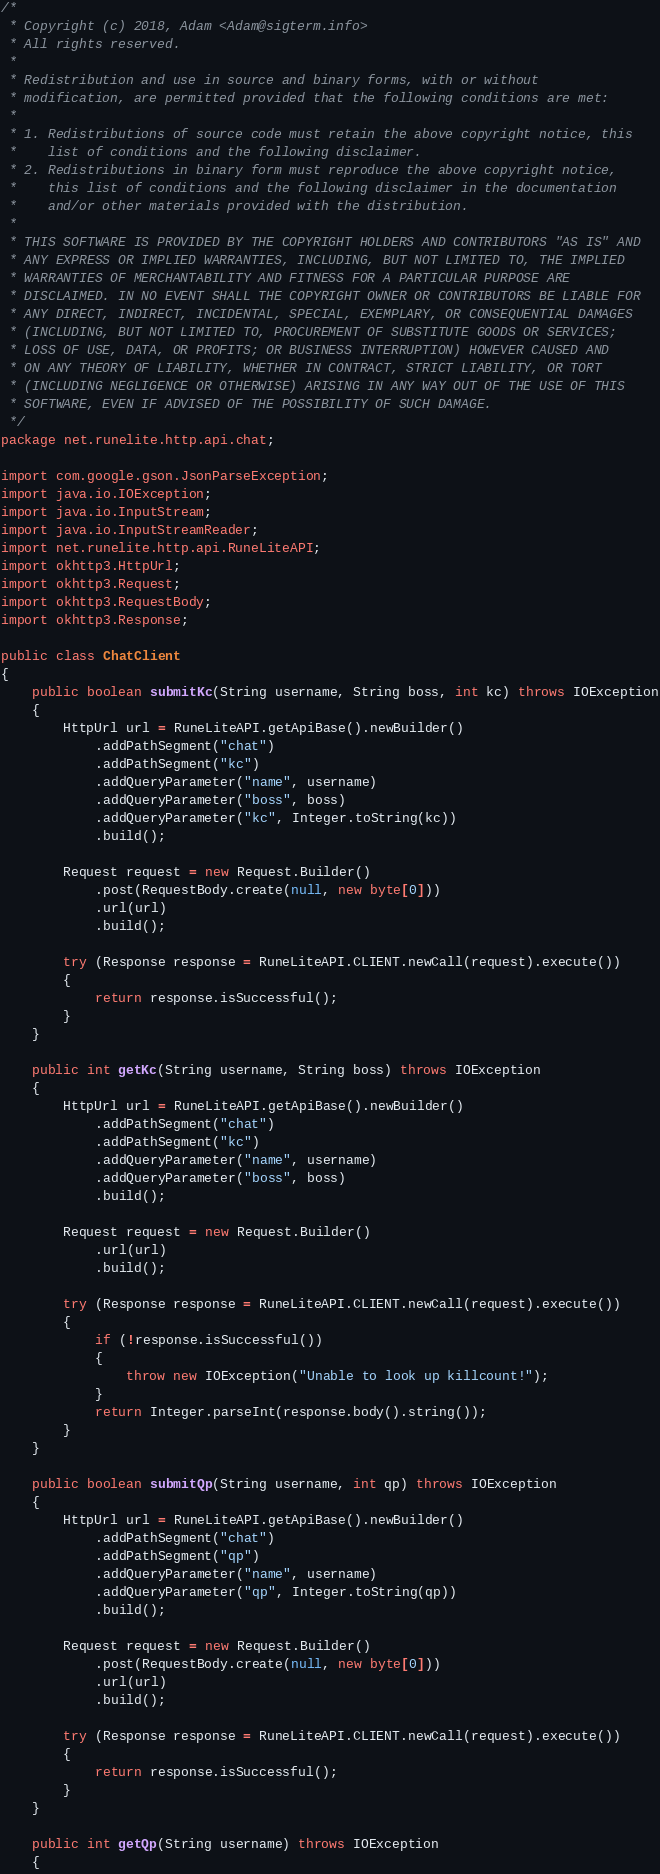Convert code to text. <code><loc_0><loc_0><loc_500><loc_500><_Java_>/*
 * Copyright (c) 2018, Adam <Adam@sigterm.info>
 * All rights reserved.
 *
 * Redistribution and use in source and binary forms, with or without
 * modification, are permitted provided that the following conditions are met:
 *
 * 1. Redistributions of source code must retain the above copyright notice, this
 *    list of conditions and the following disclaimer.
 * 2. Redistributions in binary form must reproduce the above copyright notice,
 *    this list of conditions and the following disclaimer in the documentation
 *    and/or other materials provided with the distribution.
 *
 * THIS SOFTWARE IS PROVIDED BY THE COPYRIGHT HOLDERS AND CONTRIBUTORS "AS IS" AND
 * ANY EXPRESS OR IMPLIED WARRANTIES, INCLUDING, BUT NOT LIMITED TO, THE IMPLIED
 * WARRANTIES OF MERCHANTABILITY AND FITNESS FOR A PARTICULAR PURPOSE ARE
 * DISCLAIMED. IN NO EVENT SHALL THE COPYRIGHT OWNER OR CONTRIBUTORS BE LIABLE FOR
 * ANY DIRECT, INDIRECT, INCIDENTAL, SPECIAL, EXEMPLARY, OR CONSEQUENTIAL DAMAGES
 * (INCLUDING, BUT NOT LIMITED TO, PROCUREMENT OF SUBSTITUTE GOODS OR SERVICES;
 * LOSS OF USE, DATA, OR PROFITS; OR BUSINESS INTERRUPTION) HOWEVER CAUSED AND
 * ON ANY THEORY OF LIABILITY, WHETHER IN CONTRACT, STRICT LIABILITY, OR TORT
 * (INCLUDING NEGLIGENCE OR OTHERWISE) ARISING IN ANY WAY OUT OF THE USE OF THIS
 * SOFTWARE, EVEN IF ADVISED OF THE POSSIBILITY OF SUCH DAMAGE.
 */
package net.runelite.http.api.chat;

import com.google.gson.JsonParseException;
import java.io.IOException;
import java.io.InputStream;
import java.io.InputStreamReader;
import net.runelite.http.api.RuneLiteAPI;
import okhttp3.HttpUrl;
import okhttp3.Request;
import okhttp3.RequestBody;
import okhttp3.Response;

public class ChatClient
{
	public boolean submitKc(String username, String boss, int kc) throws IOException
	{
		HttpUrl url = RuneLiteAPI.getApiBase().newBuilder()
			.addPathSegment("chat")
			.addPathSegment("kc")
			.addQueryParameter("name", username)
			.addQueryParameter("boss", boss)
			.addQueryParameter("kc", Integer.toString(kc))
			.build();

		Request request = new Request.Builder()
			.post(RequestBody.create(null, new byte[0]))
			.url(url)
			.build();

		try (Response response = RuneLiteAPI.CLIENT.newCall(request).execute())
		{
			return response.isSuccessful();
		}
	}

	public int getKc(String username, String boss) throws IOException
	{
		HttpUrl url = RuneLiteAPI.getApiBase().newBuilder()
			.addPathSegment("chat")
			.addPathSegment("kc")
			.addQueryParameter("name", username)
			.addQueryParameter("boss", boss)
			.build();

		Request request = new Request.Builder()
			.url(url)
			.build();

		try (Response response = RuneLiteAPI.CLIENT.newCall(request).execute())
		{
			if (!response.isSuccessful())
			{
				throw new IOException("Unable to look up killcount!");
			}
			return Integer.parseInt(response.body().string());
		}
	}

	public boolean submitQp(String username, int qp) throws IOException
	{
		HttpUrl url = RuneLiteAPI.getApiBase().newBuilder()
			.addPathSegment("chat")
			.addPathSegment("qp")
			.addQueryParameter("name", username)
			.addQueryParameter("qp", Integer.toString(qp))
			.build();

		Request request = new Request.Builder()
			.post(RequestBody.create(null, new byte[0]))
			.url(url)
			.build();

		try (Response response = RuneLiteAPI.CLIENT.newCall(request).execute())
		{
			return response.isSuccessful();
		}
	}

	public int getQp(String username) throws IOException
	{</code> 